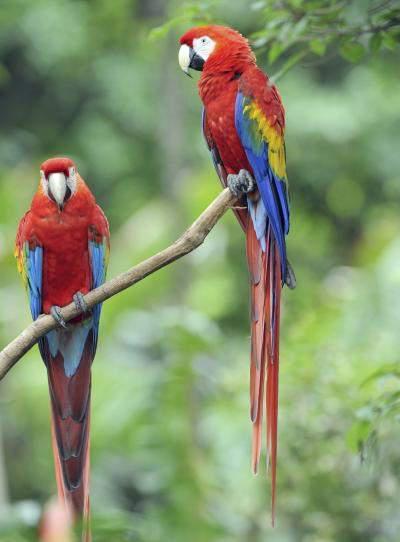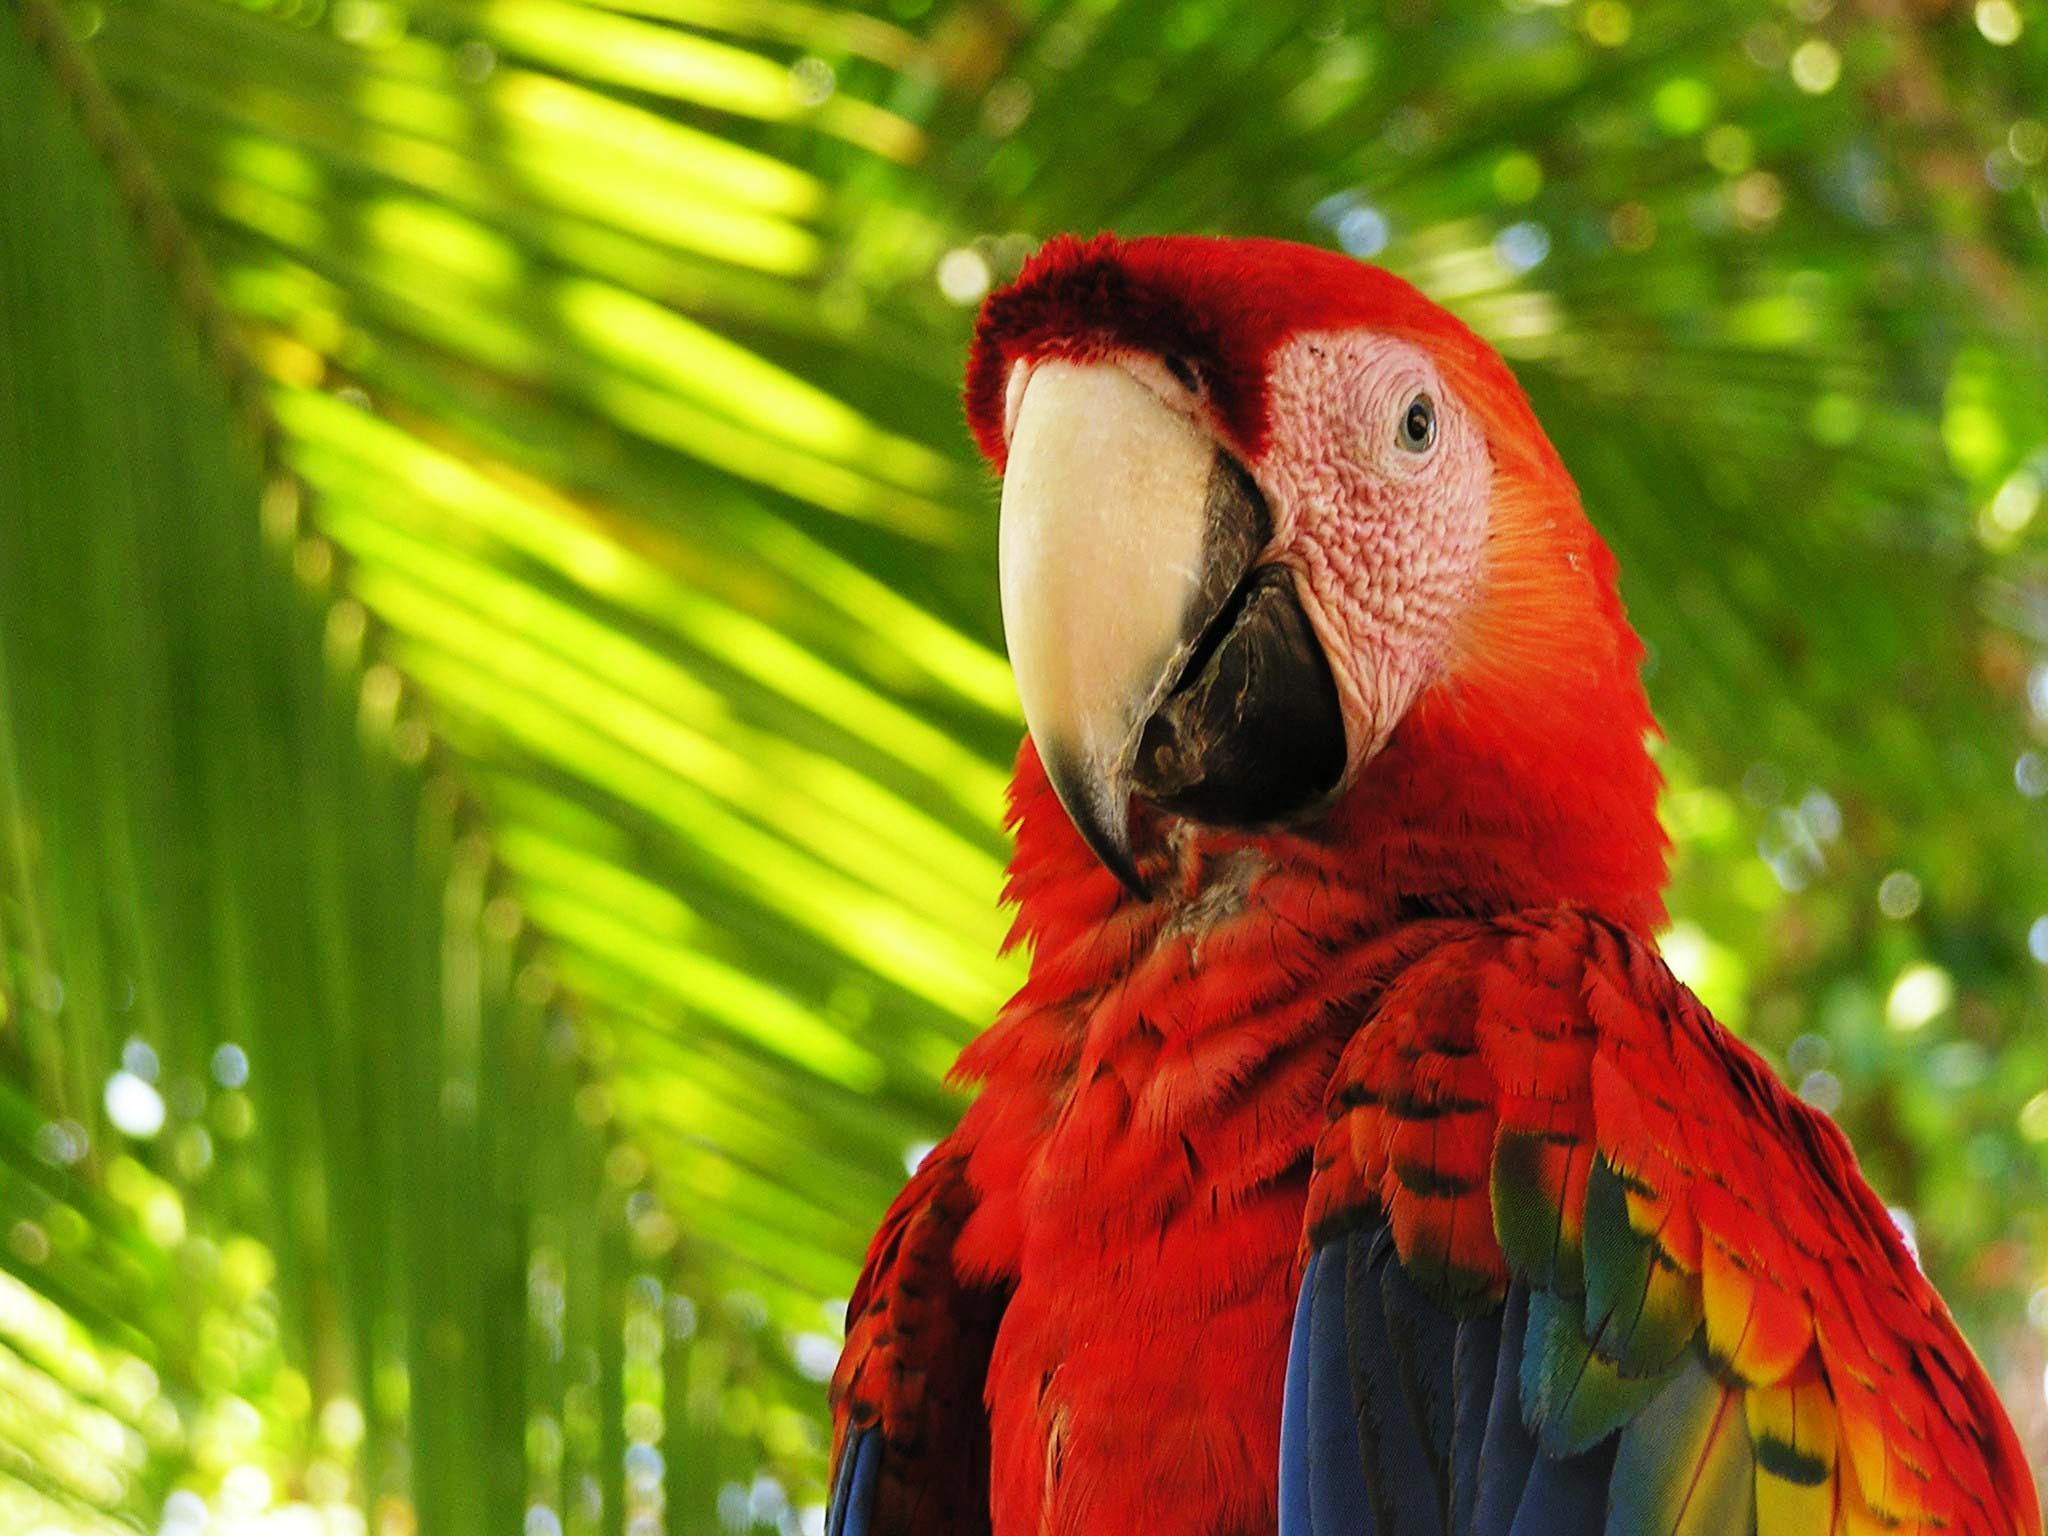The first image is the image on the left, the second image is the image on the right. Considering the images on both sides, is "At least one image contains a macaw in flight." valid? Answer yes or no. No. 